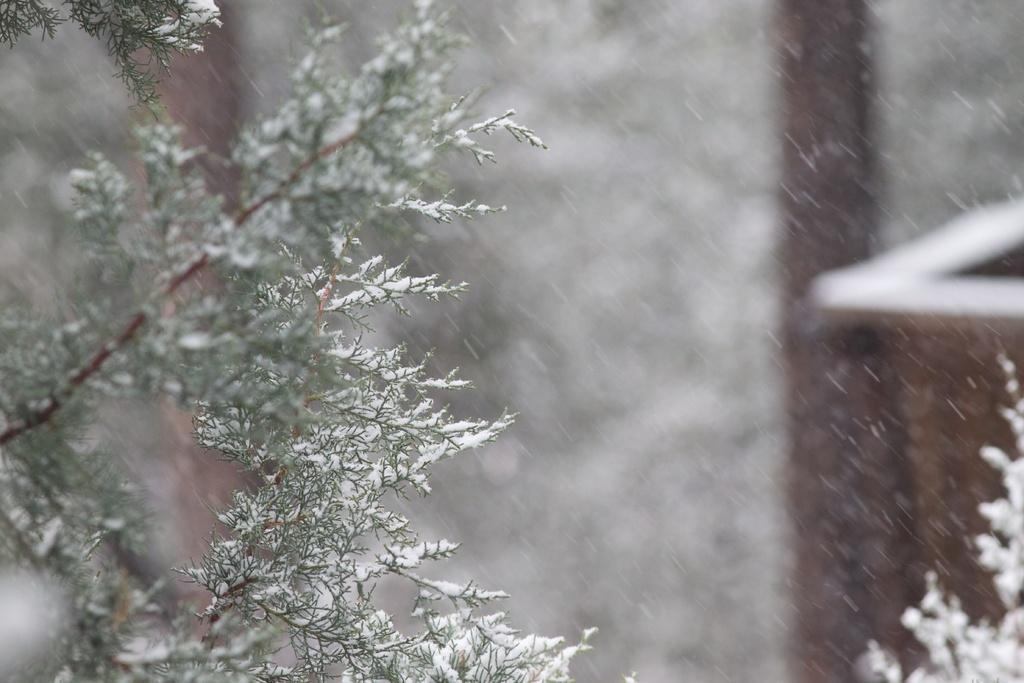In one or two sentences, can you explain what this image depicts? This picture seems to be clicked outside. On the left we can see the green leaves and the snow. On the right we can see there are some objects which seems to be the snowfall and we can see some other objects. 